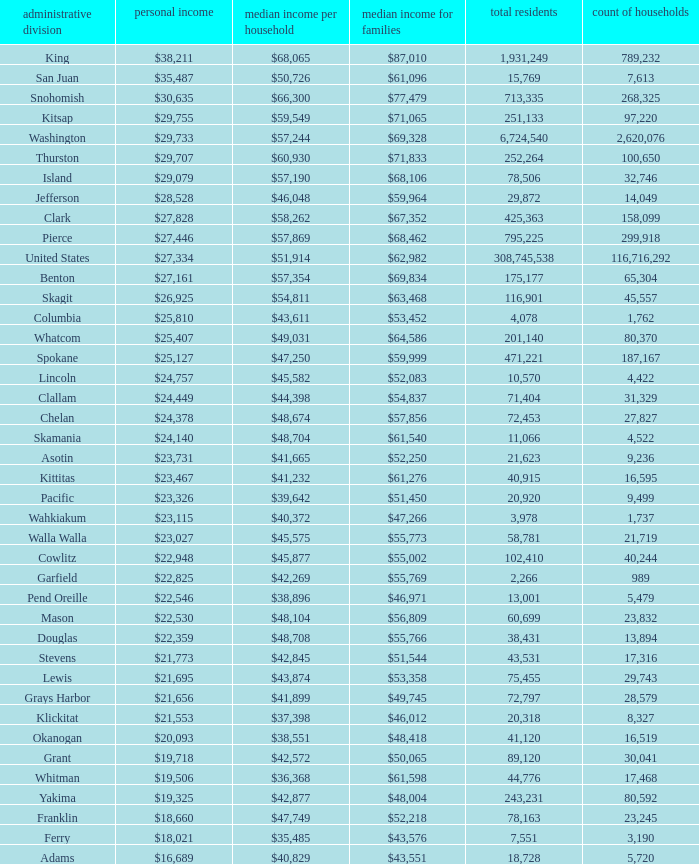How much is per capita income when median household income is $42,845? $21,773. 